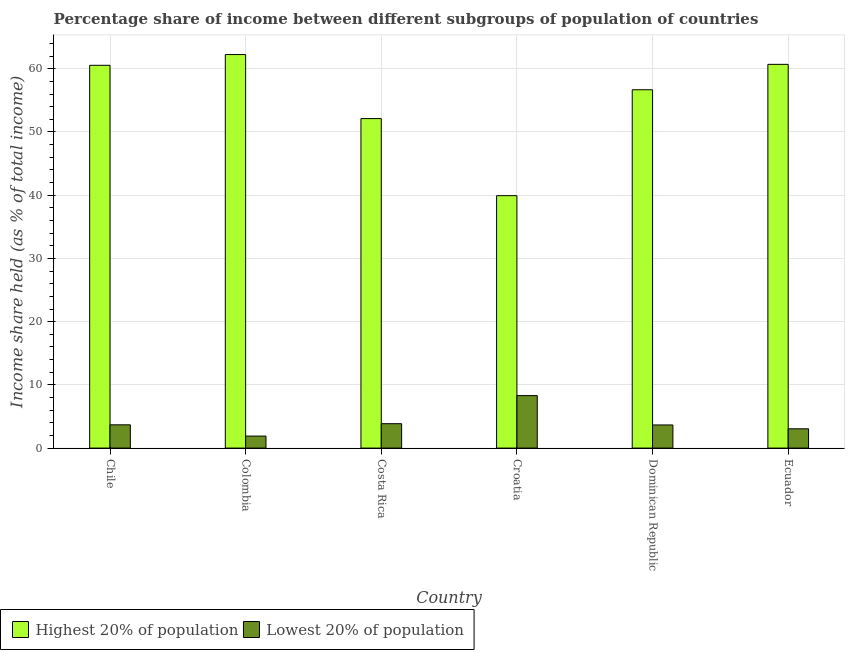How many groups of bars are there?
Offer a terse response. 6. Are the number of bars per tick equal to the number of legend labels?
Provide a short and direct response. Yes. Are the number of bars on each tick of the X-axis equal?
Offer a terse response. Yes. How many bars are there on the 5th tick from the left?
Ensure brevity in your answer.  2. What is the label of the 4th group of bars from the left?
Give a very brief answer. Croatia. What is the income share held by highest 20% of the population in Ecuador?
Offer a terse response. 60.7. Across all countries, what is the maximum income share held by highest 20% of the population?
Make the answer very short. 62.25. In which country was the income share held by lowest 20% of the population maximum?
Ensure brevity in your answer.  Croatia. In which country was the income share held by lowest 20% of the population minimum?
Your answer should be compact. Colombia. What is the total income share held by lowest 20% of the population in the graph?
Offer a very short reply. 24.45. What is the difference between the income share held by lowest 20% of the population in Chile and that in Croatia?
Provide a short and direct response. -4.62. What is the difference between the income share held by lowest 20% of the population in Croatia and the income share held by highest 20% of the population in Chile?
Provide a short and direct response. -52.25. What is the average income share held by highest 20% of the population per country?
Provide a succinct answer. 55.37. What is the difference between the income share held by lowest 20% of the population and income share held by highest 20% of the population in Croatia?
Your answer should be compact. -31.63. In how many countries, is the income share held by highest 20% of the population greater than 20 %?
Provide a succinct answer. 6. What is the ratio of the income share held by highest 20% of the population in Chile to that in Costa Rica?
Provide a short and direct response. 1.16. Is the income share held by lowest 20% of the population in Costa Rica less than that in Croatia?
Your answer should be compact. Yes. Is the difference between the income share held by highest 20% of the population in Croatia and Dominican Republic greater than the difference between the income share held by lowest 20% of the population in Croatia and Dominican Republic?
Your response must be concise. No. What is the difference between the highest and the second highest income share held by lowest 20% of the population?
Your answer should be compact. 4.44. What is the difference between the highest and the lowest income share held by lowest 20% of the population?
Your answer should be very brief. 6.4. In how many countries, is the income share held by lowest 20% of the population greater than the average income share held by lowest 20% of the population taken over all countries?
Your answer should be compact. 1. Is the sum of the income share held by lowest 20% of the population in Colombia and Costa Rica greater than the maximum income share held by highest 20% of the population across all countries?
Keep it short and to the point. No. What does the 2nd bar from the left in Chile represents?
Keep it short and to the point. Lowest 20% of population. What does the 2nd bar from the right in Ecuador represents?
Provide a succinct answer. Highest 20% of population. Does the graph contain any zero values?
Offer a very short reply. No. Does the graph contain grids?
Ensure brevity in your answer.  Yes. How many legend labels are there?
Your answer should be compact. 2. How are the legend labels stacked?
Provide a succinct answer. Horizontal. What is the title of the graph?
Provide a succinct answer. Percentage share of income between different subgroups of population of countries. What is the label or title of the X-axis?
Provide a succinct answer. Country. What is the label or title of the Y-axis?
Ensure brevity in your answer.  Income share held (as % of total income). What is the Income share held (as % of total income) of Highest 20% of population in Chile?
Provide a succinct answer. 60.55. What is the Income share held (as % of total income) of Lowest 20% of population in Chile?
Offer a very short reply. 3.68. What is the Income share held (as % of total income) in Highest 20% of population in Colombia?
Offer a terse response. 62.25. What is the Income share held (as % of total income) of Highest 20% of population in Costa Rica?
Offer a very short reply. 52.12. What is the Income share held (as % of total income) of Lowest 20% of population in Costa Rica?
Ensure brevity in your answer.  3.86. What is the Income share held (as % of total income) of Highest 20% of population in Croatia?
Ensure brevity in your answer.  39.93. What is the Income share held (as % of total income) in Lowest 20% of population in Croatia?
Give a very brief answer. 8.3. What is the Income share held (as % of total income) in Highest 20% of population in Dominican Republic?
Provide a short and direct response. 56.68. What is the Income share held (as % of total income) of Lowest 20% of population in Dominican Republic?
Provide a succinct answer. 3.66. What is the Income share held (as % of total income) of Highest 20% of population in Ecuador?
Offer a very short reply. 60.7. What is the Income share held (as % of total income) in Lowest 20% of population in Ecuador?
Offer a terse response. 3.05. Across all countries, what is the maximum Income share held (as % of total income) in Highest 20% of population?
Offer a terse response. 62.25. Across all countries, what is the maximum Income share held (as % of total income) in Lowest 20% of population?
Your answer should be very brief. 8.3. Across all countries, what is the minimum Income share held (as % of total income) of Highest 20% of population?
Make the answer very short. 39.93. Across all countries, what is the minimum Income share held (as % of total income) of Lowest 20% of population?
Ensure brevity in your answer.  1.9. What is the total Income share held (as % of total income) of Highest 20% of population in the graph?
Offer a terse response. 332.23. What is the total Income share held (as % of total income) of Lowest 20% of population in the graph?
Provide a short and direct response. 24.45. What is the difference between the Income share held (as % of total income) of Lowest 20% of population in Chile and that in Colombia?
Offer a very short reply. 1.78. What is the difference between the Income share held (as % of total income) of Highest 20% of population in Chile and that in Costa Rica?
Your response must be concise. 8.43. What is the difference between the Income share held (as % of total income) of Lowest 20% of population in Chile and that in Costa Rica?
Make the answer very short. -0.18. What is the difference between the Income share held (as % of total income) of Highest 20% of population in Chile and that in Croatia?
Your response must be concise. 20.62. What is the difference between the Income share held (as % of total income) of Lowest 20% of population in Chile and that in Croatia?
Offer a terse response. -4.62. What is the difference between the Income share held (as % of total income) of Highest 20% of population in Chile and that in Dominican Republic?
Provide a succinct answer. 3.87. What is the difference between the Income share held (as % of total income) in Highest 20% of population in Chile and that in Ecuador?
Give a very brief answer. -0.15. What is the difference between the Income share held (as % of total income) in Lowest 20% of population in Chile and that in Ecuador?
Make the answer very short. 0.63. What is the difference between the Income share held (as % of total income) in Highest 20% of population in Colombia and that in Costa Rica?
Make the answer very short. 10.13. What is the difference between the Income share held (as % of total income) of Lowest 20% of population in Colombia and that in Costa Rica?
Your response must be concise. -1.96. What is the difference between the Income share held (as % of total income) of Highest 20% of population in Colombia and that in Croatia?
Provide a succinct answer. 22.32. What is the difference between the Income share held (as % of total income) in Lowest 20% of population in Colombia and that in Croatia?
Your answer should be very brief. -6.4. What is the difference between the Income share held (as % of total income) in Highest 20% of population in Colombia and that in Dominican Republic?
Make the answer very short. 5.57. What is the difference between the Income share held (as % of total income) in Lowest 20% of population in Colombia and that in Dominican Republic?
Make the answer very short. -1.76. What is the difference between the Income share held (as % of total income) of Highest 20% of population in Colombia and that in Ecuador?
Give a very brief answer. 1.55. What is the difference between the Income share held (as % of total income) in Lowest 20% of population in Colombia and that in Ecuador?
Offer a very short reply. -1.15. What is the difference between the Income share held (as % of total income) of Highest 20% of population in Costa Rica and that in Croatia?
Provide a succinct answer. 12.19. What is the difference between the Income share held (as % of total income) in Lowest 20% of population in Costa Rica and that in Croatia?
Your response must be concise. -4.44. What is the difference between the Income share held (as % of total income) in Highest 20% of population in Costa Rica and that in Dominican Republic?
Offer a terse response. -4.56. What is the difference between the Income share held (as % of total income) of Lowest 20% of population in Costa Rica and that in Dominican Republic?
Your answer should be very brief. 0.2. What is the difference between the Income share held (as % of total income) of Highest 20% of population in Costa Rica and that in Ecuador?
Give a very brief answer. -8.58. What is the difference between the Income share held (as % of total income) of Lowest 20% of population in Costa Rica and that in Ecuador?
Provide a succinct answer. 0.81. What is the difference between the Income share held (as % of total income) of Highest 20% of population in Croatia and that in Dominican Republic?
Give a very brief answer. -16.75. What is the difference between the Income share held (as % of total income) in Lowest 20% of population in Croatia and that in Dominican Republic?
Offer a terse response. 4.64. What is the difference between the Income share held (as % of total income) in Highest 20% of population in Croatia and that in Ecuador?
Ensure brevity in your answer.  -20.77. What is the difference between the Income share held (as % of total income) in Lowest 20% of population in Croatia and that in Ecuador?
Give a very brief answer. 5.25. What is the difference between the Income share held (as % of total income) in Highest 20% of population in Dominican Republic and that in Ecuador?
Offer a very short reply. -4.02. What is the difference between the Income share held (as % of total income) in Lowest 20% of population in Dominican Republic and that in Ecuador?
Your answer should be compact. 0.61. What is the difference between the Income share held (as % of total income) in Highest 20% of population in Chile and the Income share held (as % of total income) in Lowest 20% of population in Colombia?
Make the answer very short. 58.65. What is the difference between the Income share held (as % of total income) in Highest 20% of population in Chile and the Income share held (as % of total income) in Lowest 20% of population in Costa Rica?
Make the answer very short. 56.69. What is the difference between the Income share held (as % of total income) of Highest 20% of population in Chile and the Income share held (as % of total income) of Lowest 20% of population in Croatia?
Give a very brief answer. 52.25. What is the difference between the Income share held (as % of total income) in Highest 20% of population in Chile and the Income share held (as % of total income) in Lowest 20% of population in Dominican Republic?
Offer a terse response. 56.89. What is the difference between the Income share held (as % of total income) of Highest 20% of population in Chile and the Income share held (as % of total income) of Lowest 20% of population in Ecuador?
Offer a terse response. 57.5. What is the difference between the Income share held (as % of total income) in Highest 20% of population in Colombia and the Income share held (as % of total income) in Lowest 20% of population in Costa Rica?
Ensure brevity in your answer.  58.39. What is the difference between the Income share held (as % of total income) of Highest 20% of population in Colombia and the Income share held (as % of total income) of Lowest 20% of population in Croatia?
Provide a succinct answer. 53.95. What is the difference between the Income share held (as % of total income) of Highest 20% of population in Colombia and the Income share held (as % of total income) of Lowest 20% of population in Dominican Republic?
Your answer should be compact. 58.59. What is the difference between the Income share held (as % of total income) in Highest 20% of population in Colombia and the Income share held (as % of total income) in Lowest 20% of population in Ecuador?
Give a very brief answer. 59.2. What is the difference between the Income share held (as % of total income) of Highest 20% of population in Costa Rica and the Income share held (as % of total income) of Lowest 20% of population in Croatia?
Your answer should be compact. 43.82. What is the difference between the Income share held (as % of total income) in Highest 20% of population in Costa Rica and the Income share held (as % of total income) in Lowest 20% of population in Dominican Republic?
Your answer should be compact. 48.46. What is the difference between the Income share held (as % of total income) of Highest 20% of population in Costa Rica and the Income share held (as % of total income) of Lowest 20% of population in Ecuador?
Keep it short and to the point. 49.07. What is the difference between the Income share held (as % of total income) in Highest 20% of population in Croatia and the Income share held (as % of total income) in Lowest 20% of population in Dominican Republic?
Your answer should be very brief. 36.27. What is the difference between the Income share held (as % of total income) in Highest 20% of population in Croatia and the Income share held (as % of total income) in Lowest 20% of population in Ecuador?
Ensure brevity in your answer.  36.88. What is the difference between the Income share held (as % of total income) of Highest 20% of population in Dominican Republic and the Income share held (as % of total income) of Lowest 20% of population in Ecuador?
Make the answer very short. 53.63. What is the average Income share held (as % of total income) in Highest 20% of population per country?
Keep it short and to the point. 55.37. What is the average Income share held (as % of total income) of Lowest 20% of population per country?
Your answer should be compact. 4.08. What is the difference between the Income share held (as % of total income) of Highest 20% of population and Income share held (as % of total income) of Lowest 20% of population in Chile?
Provide a succinct answer. 56.87. What is the difference between the Income share held (as % of total income) of Highest 20% of population and Income share held (as % of total income) of Lowest 20% of population in Colombia?
Provide a succinct answer. 60.35. What is the difference between the Income share held (as % of total income) of Highest 20% of population and Income share held (as % of total income) of Lowest 20% of population in Costa Rica?
Offer a terse response. 48.26. What is the difference between the Income share held (as % of total income) in Highest 20% of population and Income share held (as % of total income) in Lowest 20% of population in Croatia?
Give a very brief answer. 31.63. What is the difference between the Income share held (as % of total income) in Highest 20% of population and Income share held (as % of total income) in Lowest 20% of population in Dominican Republic?
Provide a succinct answer. 53.02. What is the difference between the Income share held (as % of total income) in Highest 20% of population and Income share held (as % of total income) in Lowest 20% of population in Ecuador?
Provide a short and direct response. 57.65. What is the ratio of the Income share held (as % of total income) of Highest 20% of population in Chile to that in Colombia?
Offer a very short reply. 0.97. What is the ratio of the Income share held (as % of total income) of Lowest 20% of population in Chile to that in Colombia?
Keep it short and to the point. 1.94. What is the ratio of the Income share held (as % of total income) of Highest 20% of population in Chile to that in Costa Rica?
Make the answer very short. 1.16. What is the ratio of the Income share held (as % of total income) in Lowest 20% of population in Chile to that in Costa Rica?
Your answer should be compact. 0.95. What is the ratio of the Income share held (as % of total income) of Highest 20% of population in Chile to that in Croatia?
Your response must be concise. 1.52. What is the ratio of the Income share held (as % of total income) of Lowest 20% of population in Chile to that in Croatia?
Give a very brief answer. 0.44. What is the ratio of the Income share held (as % of total income) in Highest 20% of population in Chile to that in Dominican Republic?
Offer a terse response. 1.07. What is the ratio of the Income share held (as % of total income) of Lowest 20% of population in Chile to that in Dominican Republic?
Provide a short and direct response. 1.01. What is the ratio of the Income share held (as % of total income) in Lowest 20% of population in Chile to that in Ecuador?
Ensure brevity in your answer.  1.21. What is the ratio of the Income share held (as % of total income) of Highest 20% of population in Colombia to that in Costa Rica?
Make the answer very short. 1.19. What is the ratio of the Income share held (as % of total income) of Lowest 20% of population in Colombia to that in Costa Rica?
Give a very brief answer. 0.49. What is the ratio of the Income share held (as % of total income) of Highest 20% of population in Colombia to that in Croatia?
Make the answer very short. 1.56. What is the ratio of the Income share held (as % of total income) of Lowest 20% of population in Colombia to that in Croatia?
Ensure brevity in your answer.  0.23. What is the ratio of the Income share held (as % of total income) in Highest 20% of population in Colombia to that in Dominican Republic?
Ensure brevity in your answer.  1.1. What is the ratio of the Income share held (as % of total income) in Lowest 20% of population in Colombia to that in Dominican Republic?
Give a very brief answer. 0.52. What is the ratio of the Income share held (as % of total income) in Highest 20% of population in Colombia to that in Ecuador?
Offer a very short reply. 1.03. What is the ratio of the Income share held (as % of total income) in Lowest 20% of population in Colombia to that in Ecuador?
Offer a terse response. 0.62. What is the ratio of the Income share held (as % of total income) of Highest 20% of population in Costa Rica to that in Croatia?
Offer a very short reply. 1.31. What is the ratio of the Income share held (as % of total income) of Lowest 20% of population in Costa Rica to that in Croatia?
Your answer should be very brief. 0.47. What is the ratio of the Income share held (as % of total income) in Highest 20% of population in Costa Rica to that in Dominican Republic?
Give a very brief answer. 0.92. What is the ratio of the Income share held (as % of total income) in Lowest 20% of population in Costa Rica to that in Dominican Republic?
Offer a very short reply. 1.05. What is the ratio of the Income share held (as % of total income) in Highest 20% of population in Costa Rica to that in Ecuador?
Give a very brief answer. 0.86. What is the ratio of the Income share held (as % of total income) of Lowest 20% of population in Costa Rica to that in Ecuador?
Offer a terse response. 1.27. What is the ratio of the Income share held (as % of total income) in Highest 20% of population in Croatia to that in Dominican Republic?
Ensure brevity in your answer.  0.7. What is the ratio of the Income share held (as % of total income) in Lowest 20% of population in Croatia to that in Dominican Republic?
Keep it short and to the point. 2.27. What is the ratio of the Income share held (as % of total income) of Highest 20% of population in Croatia to that in Ecuador?
Your answer should be very brief. 0.66. What is the ratio of the Income share held (as % of total income) in Lowest 20% of population in Croatia to that in Ecuador?
Provide a short and direct response. 2.72. What is the ratio of the Income share held (as % of total income) of Highest 20% of population in Dominican Republic to that in Ecuador?
Provide a succinct answer. 0.93. What is the ratio of the Income share held (as % of total income) of Lowest 20% of population in Dominican Republic to that in Ecuador?
Your answer should be very brief. 1.2. What is the difference between the highest and the second highest Income share held (as % of total income) of Highest 20% of population?
Your response must be concise. 1.55. What is the difference between the highest and the second highest Income share held (as % of total income) of Lowest 20% of population?
Give a very brief answer. 4.44. What is the difference between the highest and the lowest Income share held (as % of total income) in Highest 20% of population?
Offer a terse response. 22.32. 